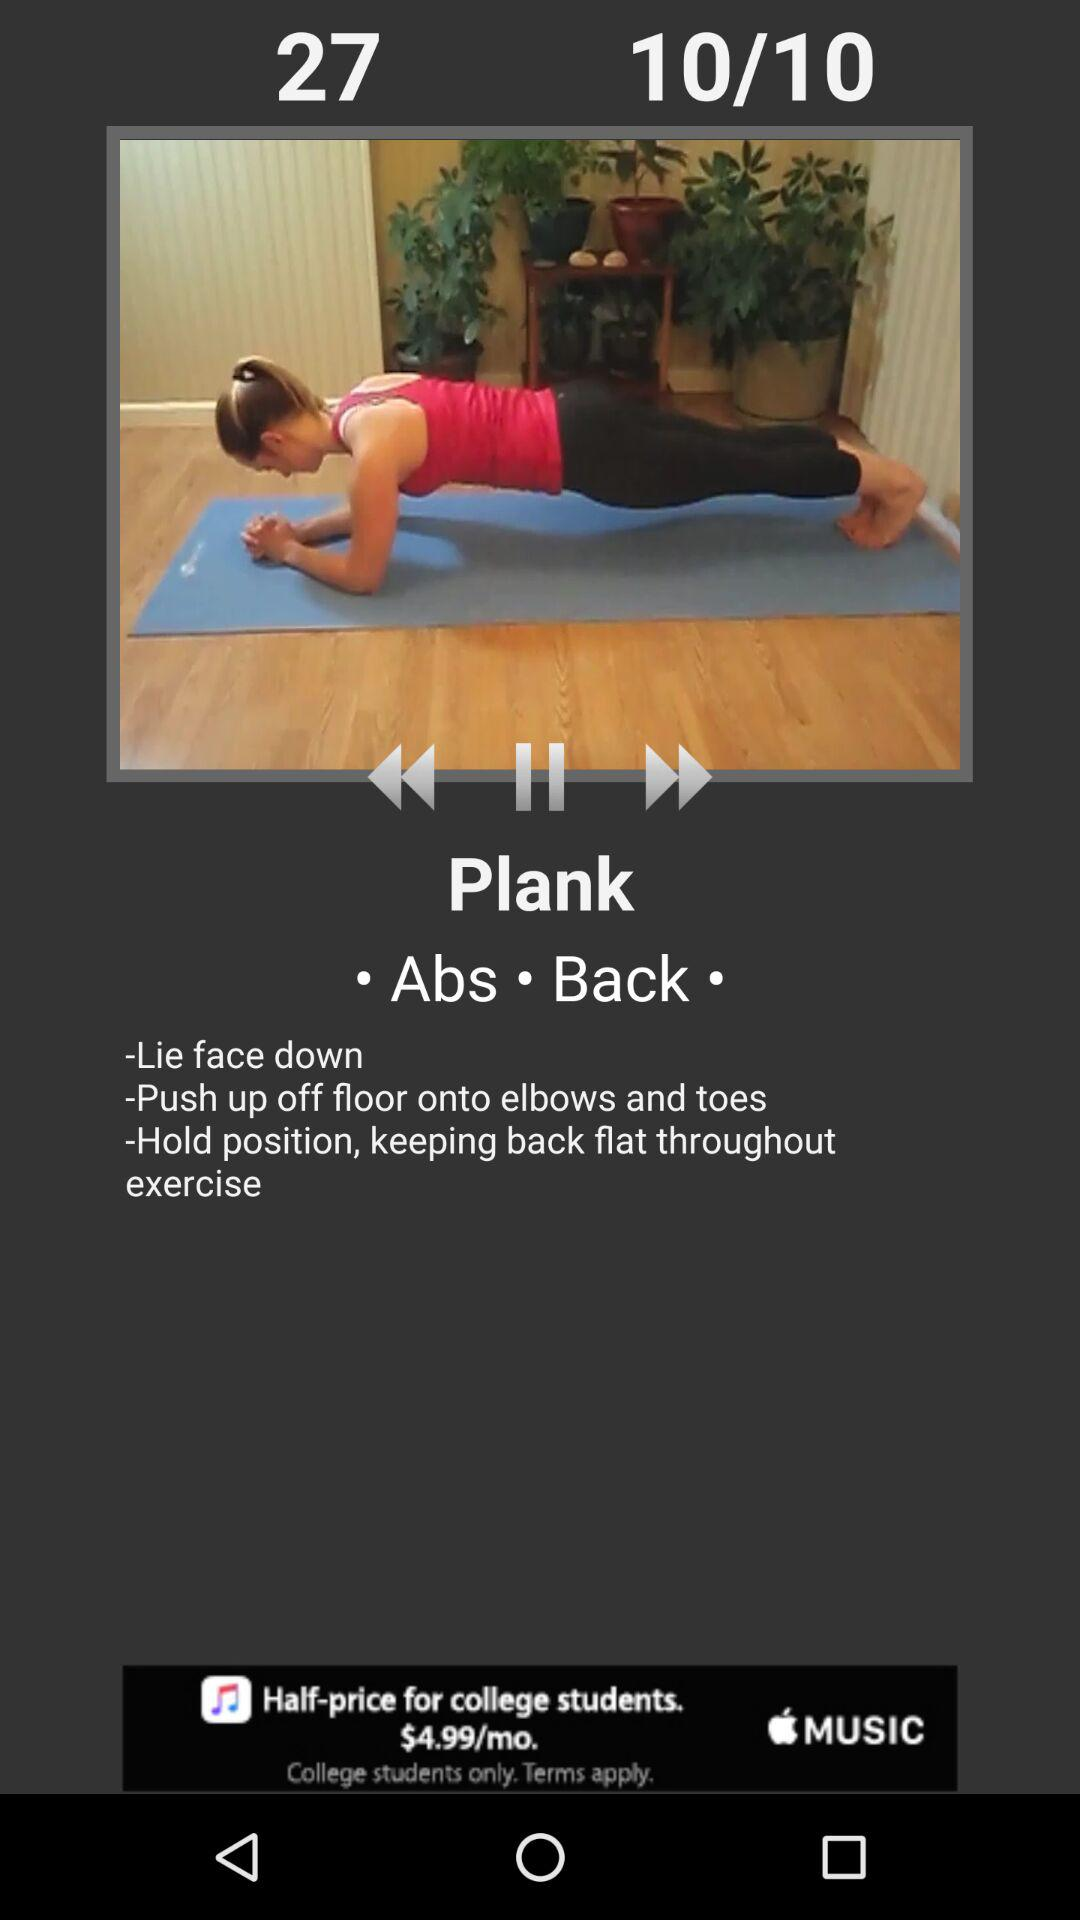How many exercises are there? There are 10 exercises. 